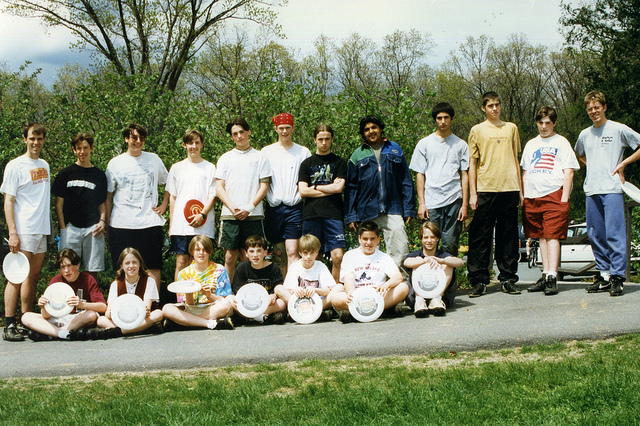<image>What agency does this picture represent? I don't know which agency this picture represents. It could be the EPA, a frisbee team, the Big Brothers, or the Boy Scouts. Why aren't two of the individuals in the picture wearing jerseys? It is ambiguous why two of the individuals in the picture aren't wearing jerseys. They might not be players. What type of team is this? I am not sure. It can be a frisbee team. What is the baseball teams name? I don't know the baseball team's name. It is not visible in the image. What agency does this picture represent? I don't know what agency does this picture represent. It can be seen 'epa', 'frisbee team', 'big brothers' or 'boy scouts'. What type of team is this? It seems like this is a frisbee team. Why aren't two of the individuals in the picture wearing jerseys? It is unknown why two of the individuals in the picture are not wearing jerseys. They might not be on the team, they might be spectators, or they might just be attending a casual event. What is the baseball teams name? It is unanswerable what the baseball team's name is. 